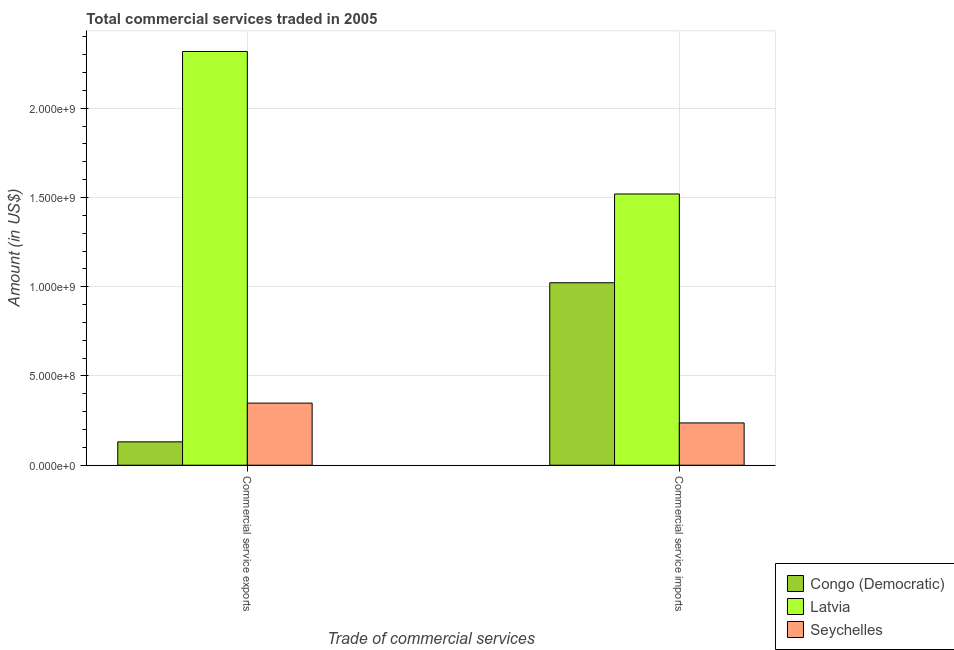How many different coloured bars are there?
Offer a very short reply. 3. Are the number of bars on each tick of the X-axis equal?
Ensure brevity in your answer.  Yes. How many bars are there on the 1st tick from the left?
Give a very brief answer. 3. How many bars are there on the 2nd tick from the right?
Offer a terse response. 3. What is the label of the 1st group of bars from the left?
Offer a terse response. Commercial service exports. What is the amount of commercial service imports in Latvia?
Your answer should be compact. 1.52e+09. Across all countries, what is the maximum amount of commercial service imports?
Keep it short and to the point. 1.52e+09. Across all countries, what is the minimum amount of commercial service exports?
Offer a very short reply. 1.31e+08. In which country was the amount of commercial service imports maximum?
Offer a terse response. Latvia. In which country was the amount of commercial service exports minimum?
Your response must be concise. Congo (Democratic). What is the total amount of commercial service imports in the graph?
Offer a very short reply. 2.78e+09. What is the difference between the amount of commercial service exports in Congo (Democratic) and that in Seychelles?
Your response must be concise. -2.17e+08. What is the difference between the amount of commercial service exports in Congo (Democratic) and the amount of commercial service imports in Latvia?
Offer a terse response. -1.39e+09. What is the average amount of commercial service imports per country?
Give a very brief answer. 9.26e+08. What is the difference between the amount of commercial service imports and amount of commercial service exports in Seychelles?
Your answer should be compact. -1.11e+08. In how many countries, is the amount of commercial service imports greater than 500000000 US$?
Your response must be concise. 2. What is the ratio of the amount of commercial service imports in Latvia to that in Congo (Democratic)?
Keep it short and to the point. 1.49. Is the amount of commercial service exports in Seychelles less than that in Latvia?
Your response must be concise. Yes. In how many countries, is the amount of commercial service exports greater than the average amount of commercial service exports taken over all countries?
Provide a short and direct response. 1. What does the 1st bar from the left in Commercial service exports represents?
Your answer should be compact. Congo (Democratic). What does the 1st bar from the right in Commercial service imports represents?
Ensure brevity in your answer.  Seychelles. Are all the bars in the graph horizontal?
Provide a short and direct response. No. Are the values on the major ticks of Y-axis written in scientific E-notation?
Keep it short and to the point. Yes. How are the legend labels stacked?
Your response must be concise. Vertical. What is the title of the graph?
Give a very brief answer. Total commercial services traded in 2005. Does "Greece" appear as one of the legend labels in the graph?
Your response must be concise. No. What is the label or title of the X-axis?
Keep it short and to the point. Trade of commercial services. What is the Amount (in US$) in Congo (Democratic) in Commercial service exports?
Your response must be concise. 1.31e+08. What is the Amount (in US$) in Latvia in Commercial service exports?
Provide a short and direct response. 2.32e+09. What is the Amount (in US$) of Seychelles in Commercial service exports?
Your response must be concise. 3.48e+08. What is the Amount (in US$) in Congo (Democratic) in Commercial service imports?
Your answer should be compact. 1.02e+09. What is the Amount (in US$) in Latvia in Commercial service imports?
Provide a short and direct response. 1.52e+09. What is the Amount (in US$) in Seychelles in Commercial service imports?
Your response must be concise. 2.37e+08. Across all Trade of commercial services, what is the maximum Amount (in US$) in Congo (Democratic)?
Offer a very short reply. 1.02e+09. Across all Trade of commercial services, what is the maximum Amount (in US$) of Latvia?
Ensure brevity in your answer.  2.32e+09. Across all Trade of commercial services, what is the maximum Amount (in US$) of Seychelles?
Provide a short and direct response. 3.48e+08. Across all Trade of commercial services, what is the minimum Amount (in US$) of Congo (Democratic)?
Ensure brevity in your answer.  1.31e+08. Across all Trade of commercial services, what is the minimum Amount (in US$) of Latvia?
Your answer should be very brief. 1.52e+09. Across all Trade of commercial services, what is the minimum Amount (in US$) of Seychelles?
Your answer should be very brief. 2.37e+08. What is the total Amount (in US$) in Congo (Democratic) in the graph?
Keep it short and to the point. 1.15e+09. What is the total Amount (in US$) in Latvia in the graph?
Provide a short and direct response. 3.84e+09. What is the total Amount (in US$) of Seychelles in the graph?
Your response must be concise. 5.85e+08. What is the difference between the Amount (in US$) in Congo (Democratic) in Commercial service exports and that in Commercial service imports?
Provide a succinct answer. -8.91e+08. What is the difference between the Amount (in US$) of Latvia in Commercial service exports and that in Commercial service imports?
Provide a short and direct response. 7.98e+08. What is the difference between the Amount (in US$) in Seychelles in Commercial service exports and that in Commercial service imports?
Ensure brevity in your answer.  1.11e+08. What is the difference between the Amount (in US$) in Congo (Democratic) in Commercial service exports and the Amount (in US$) in Latvia in Commercial service imports?
Your answer should be very brief. -1.39e+09. What is the difference between the Amount (in US$) in Congo (Democratic) in Commercial service exports and the Amount (in US$) in Seychelles in Commercial service imports?
Your answer should be very brief. -1.06e+08. What is the difference between the Amount (in US$) of Latvia in Commercial service exports and the Amount (in US$) of Seychelles in Commercial service imports?
Offer a very short reply. 2.08e+09. What is the average Amount (in US$) of Congo (Democratic) per Trade of commercial services?
Give a very brief answer. 5.77e+08. What is the average Amount (in US$) in Latvia per Trade of commercial services?
Provide a succinct answer. 1.92e+09. What is the average Amount (in US$) of Seychelles per Trade of commercial services?
Make the answer very short. 2.92e+08. What is the difference between the Amount (in US$) of Congo (Democratic) and Amount (in US$) of Latvia in Commercial service exports?
Offer a terse response. -2.19e+09. What is the difference between the Amount (in US$) in Congo (Democratic) and Amount (in US$) in Seychelles in Commercial service exports?
Your response must be concise. -2.17e+08. What is the difference between the Amount (in US$) in Latvia and Amount (in US$) in Seychelles in Commercial service exports?
Keep it short and to the point. 1.97e+09. What is the difference between the Amount (in US$) of Congo (Democratic) and Amount (in US$) of Latvia in Commercial service imports?
Make the answer very short. -4.97e+08. What is the difference between the Amount (in US$) of Congo (Democratic) and Amount (in US$) of Seychelles in Commercial service imports?
Your answer should be very brief. 7.85e+08. What is the difference between the Amount (in US$) of Latvia and Amount (in US$) of Seychelles in Commercial service imports?
Offer a very short reply. 1.28e+09. What is the ratio of the Amount (in US$) in Congo (Democratic) in Commercial service exports to that in Commercial service imports?
Your answer should be very brief. 0.13. What is the ratio of the Amount (in US$) of Latvia in Commercial service exports to that in Commercial service imports?
Make the answer very short. 1.53. What is the ratio of the Amount (in US$) in Seychelles in Commercial service exports to that in Commercial service imports?
Offer a terse response. 1.47. What is the difference between the highest and the second highest Amount (in US$) in Congo (Democratic)?
Ensure brevity in your answer.  8.91e+08. What is the difference between the highest and the second highest Amount (in US$) of Latvia?
Offer a terse response. 7.98e+08. What is the difference between the highest and the second highest Amount (in US$) of Seychelles?
Provide a short and direct response. 1.11e+08. What is the difference between the highest and the lowest Amount (in US$) in Congo (Democratic)?
Give a very brief answer. 8.91e+08. What is the difference between the highest and the lowest Amount (in US$) in Latvia?
Provide a succinct answer. 7.98e+08. What is the difference between the highest and the lowest Amount (in US$) of Seychelles?
Your answer should be compact. 1.11e+08. 